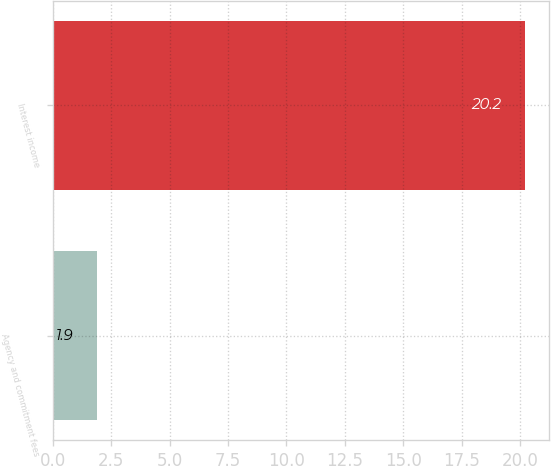Convert chart. <chart><loc_0><loc_0><loc_500><loc_500><bar_chart><fcel>Agency and commitment fees<fcel>Interest income<nl><fcel>1.9<fcel>20.2<nl></chart> 